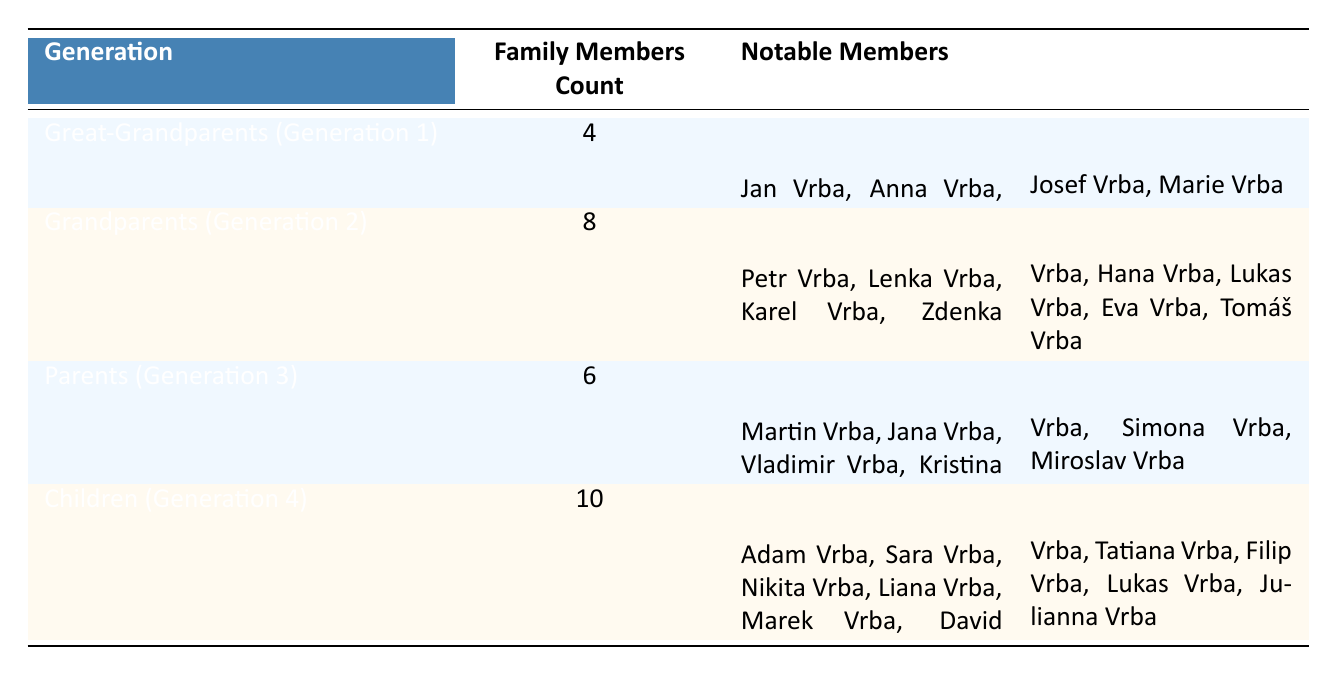What is the total number of family members across all generations? To find the total number of family members, I need to add the members from each generation: 4 (Great-Grandparents) + 8 (Grandparents) + 6 (Parents) + 10 (Children) = 28.
Answer: 28 Which generation has the highest number of family members? By comparing the family members count across generations, I see that Children (Generation 4) has 10 members, which is the highest compared to 4, 8, and 6 for the other generations.
Answer: Children (Generation 4) Is there an equal number of notable members in each generation? To answer this, I look at the notable members listed. There are 4 notable members in Generation 1, 8 notable members in Generation 2, 6 notable members in Generation 3, and 10 notable members in Generation 4. Therefore, they are not equal.
Answer: No How many more family members are there in Generation 2 than in Generation 3? To find the difference, I subtract the number of family members in Generation 3 from those in Generation 2: 8 (Generation 2) - 6 (Generation 3) = 2.
Answer: 2 What is the average number of family members per generation? There are 4 generations, and the total number of family members is 28. To find the average, I divide the total by the number of generations: 28 / 4 = 7.
Answer: 7 Do all notable members from Generation 1 have a different first name than those in Generation 2? In Generation 1, the notable members are Jan, Anna, Josef, and Marie. In Generation 2, the notable members are Petr, Lenka, Karel, Zdenka, Hana, Lukas, Eva, and Tomáš. Since there are no overlapping names, the statement is true.
Answer: Yes If the notable members of Generation 4 were listed alphabetically, would "David Vrba" come before "Liana Vrba"? To check the order of names, I look at the list for Generation 4: Adam, Sara, Nikita, Liana, Marek, David, Tatiana, Filip, Lukas, Julianna. "David" comes before "Liana" in their alphabetical order.
Answer: Yes How many family members are listed in the four generations combined if we exclude Generation 1? To find this, I add the family members in Generations 2, 3, and 4: 8 (Generation 2) + 6 (Generation 3) + 10 (Generation 4) = 24.
Answer: 24 Which generation has a total of 6 family members? By examining the family members count, I find that Parents (Generation 3) contains exactly 6 members.
Answer: Parents (Generation 3) 